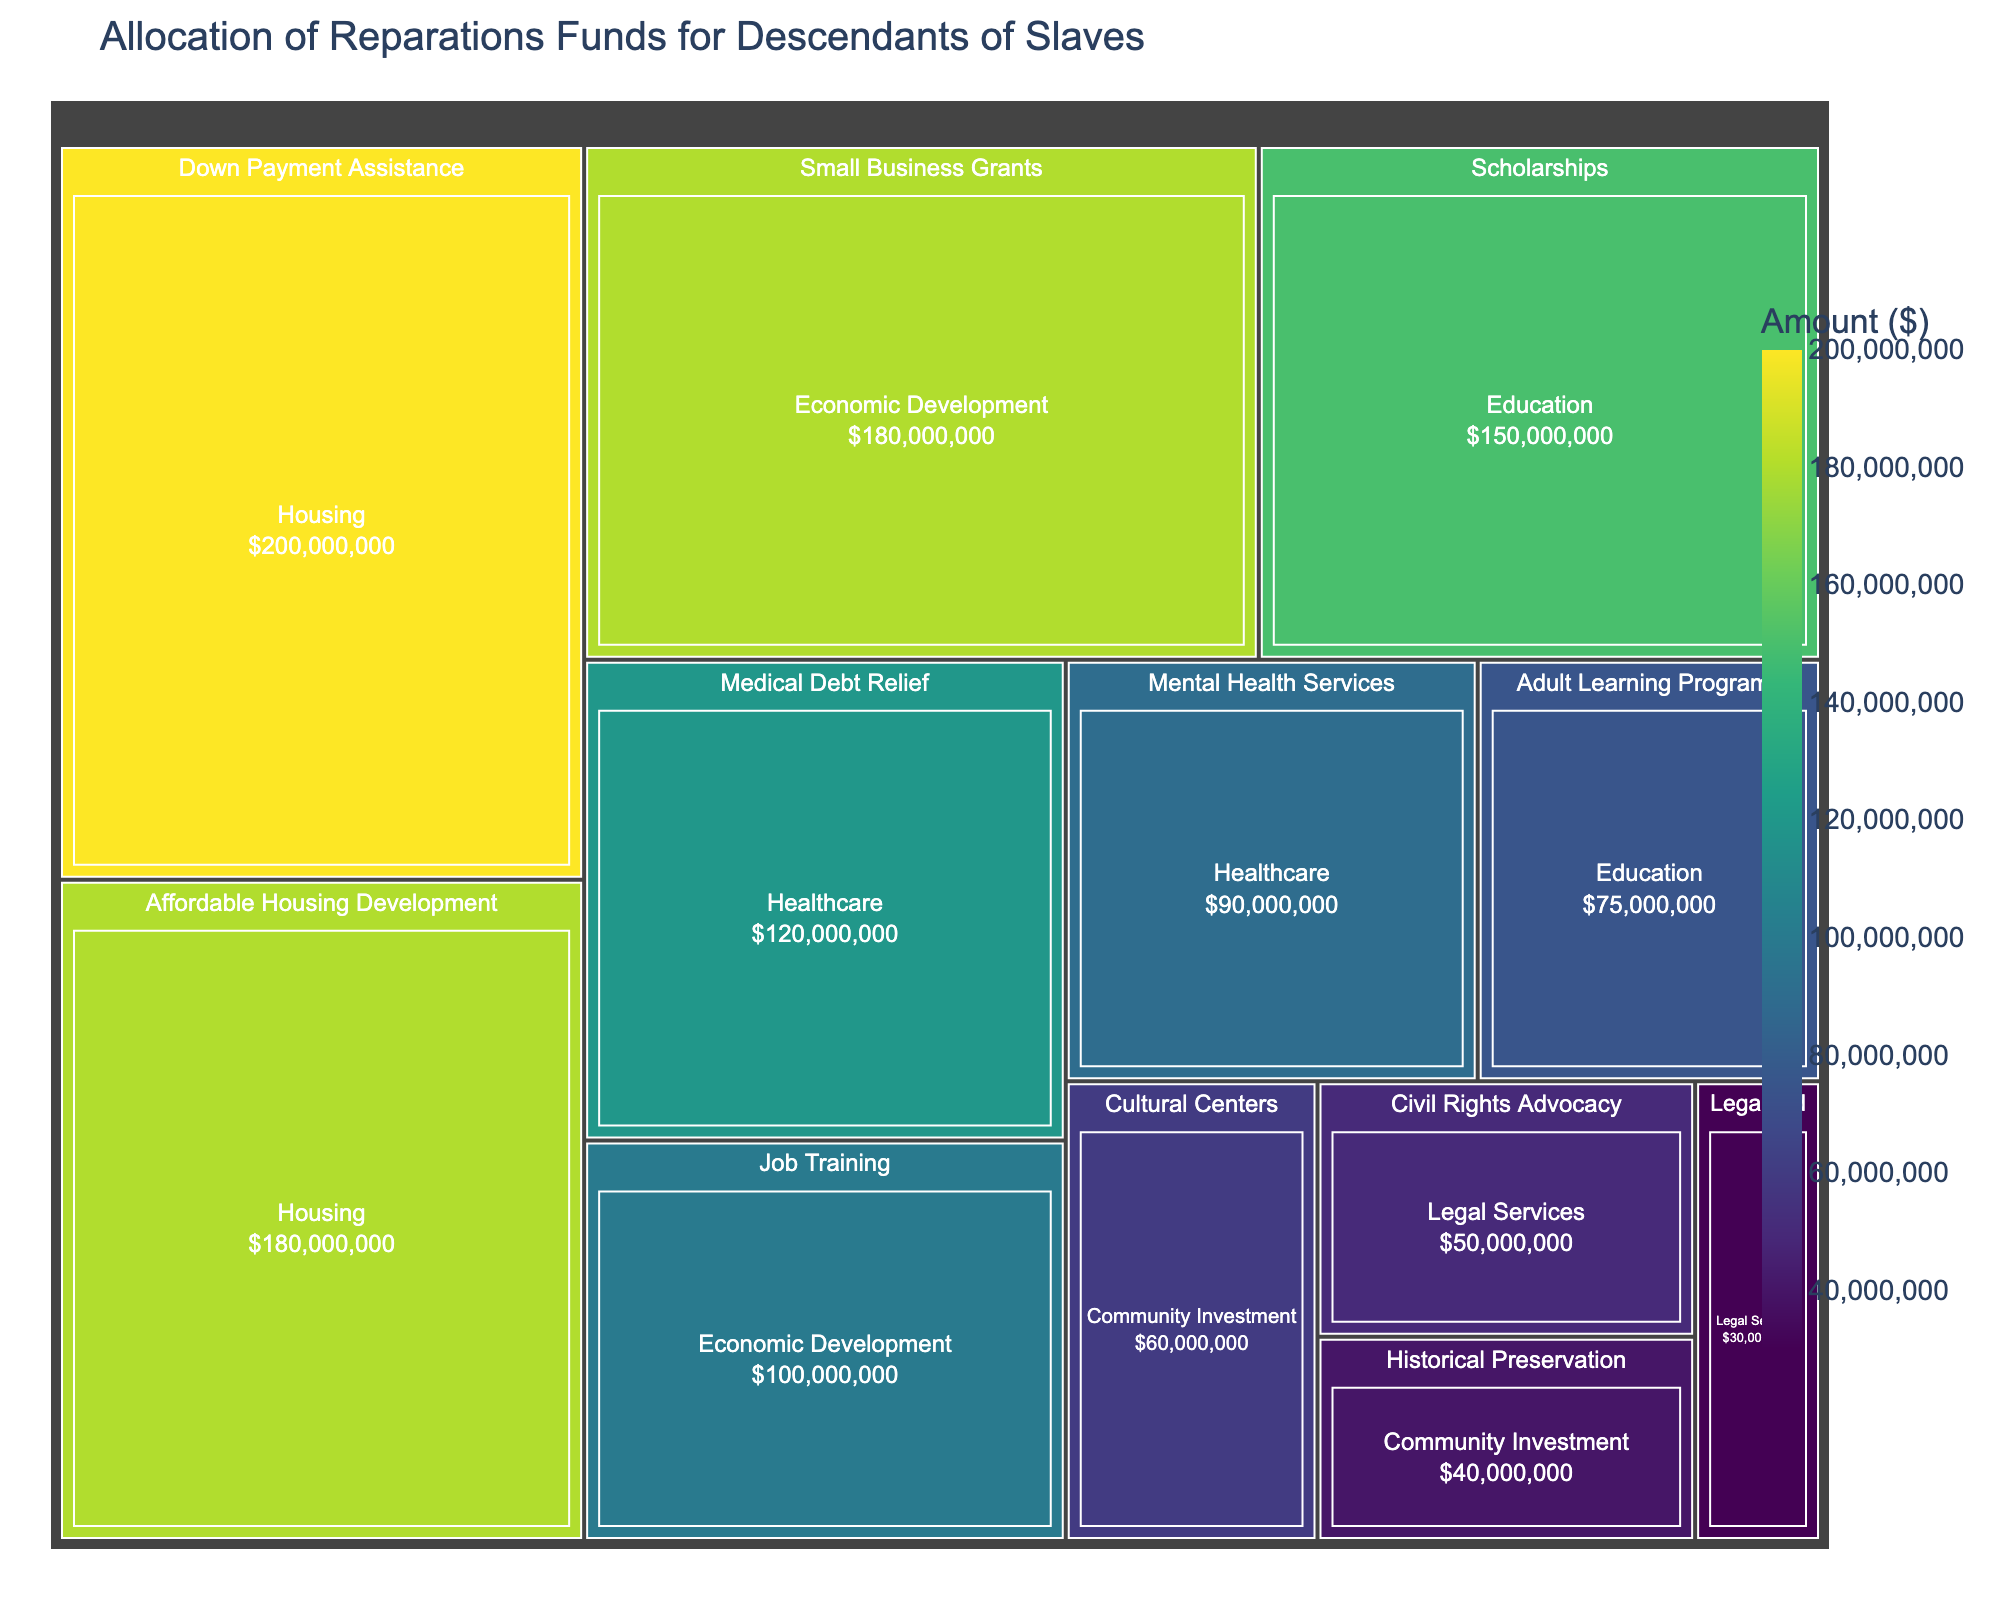How much total funding is allocated to the "Healthcare" program? The "Healthcare" program is divided into two categories: Medical Debt Relief ($120,000,000) and Mental Health Services ($90,000,000). Adding these amounts together gives: $120,000,000 + $90,000,000 = $210,000,000
Answer: $210,000,000 Which single category received the highest amount of funding? The "Down Payment Assistance" category under "Housing" received $200,000,000, which is the highest amount of funding among all listed categories.
Answer: Down Payment Assistance What is the total funding allocated to "Education"? The total funding for "Education" includes Scholarships ($150,000,000) and Adult Learning Programs ($75,000,000). Adding these amounts together gives: $150,000,000 + $75,000,000 = $225,000,000
Answer: $225,000,000 How does the funding for "Affordable Housing Development" compare to "Small Business Grants"? "Affordable Housing Development" received $180,000,000 whereas "Small Business Grants" also received $180,000,000. Both categories received equal amounts of funding.
Answer: They are equal Which program received a higher amount of funding, "Economic Development" or "Community Investment"? "Economic Development" includes Small Business Grants ($180,000,000) and Job Training ($100,000,000), totaling $280,000,000. "Community Investment" includes Cultural Centers ($60,000,000) and Historical Preservation ($40,000,000), totaling $100,000,000. Therefore, "Economic Development" received more funding.
Answer: Economic Development How much less is the funding for "Legal Aid" compared to "Civil Rights Advocacy"? "Legal Aid" received $30,000,000 and "Civil Rights Advocacy" received $50,000,000. The difference is $50,000,000 - $30,000,000 = $20,000,000
Answer: $20,000,000 What percentage of the total funding is allocated to "Job Training"? The total funding is $1,275,000,000. "Job Training" received $100,000,000. The percentage is ($100,000,000 / $1,275,000,000) * 100 = 7.84%
Answer: 7.84% Which category in the "Community Investment" program received more funding? The "Community Investment" program includes Cultural Centers ($60,000,000) and Historical Preservation ($40,000,000). Cultural Centers received more funding.
Answer: Cultural Centers 